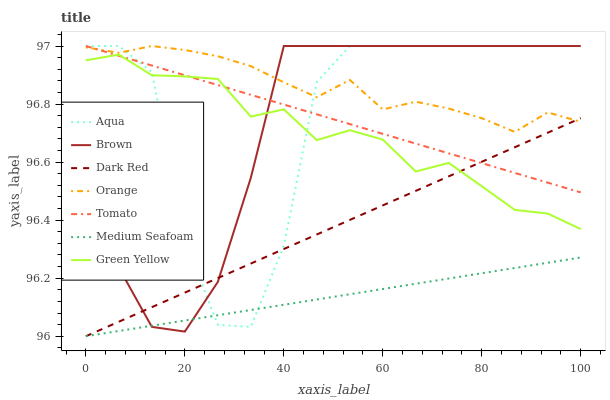Does Medium Seafoam have the minimum area under the curve?
Answer yes or no. Yes. Does Orange have the maximum area under the curve?
Answer yes or no. Yes. Does Brown have the minimum area under the curve?
Answer yes or no. No. Does Brown have the maximum area under the curve?
Answer yes or no. No. Is Tomato the smoothest?
Answer yes or no. Yes. Is Aqua the roughest?
Answer yes or no. Yes. Is Brown the smoothest?
Answer yes or no. No. Is Brown the roughest?
Answer yes or no. No. Does Dark Red have the lowest value?
Answer yes or no. Yes. Does Brown have the lowest value?
Answer yes or no. No. Does Orange have the highest value?
Answer yes or no. Yes. Does Dark Red have the highest value?
Answer yes or no. No. Is Medium Seafoam less than Green Yellow?
Answer yes or no. Yes. Is Orange greater than Green Yellow?
Answer yes or no. Yes. Does Brown intersect Aqua?
Answer yes or no. Yes. Is Brown less than Aqua?
Answer yes or no. No. Is Brown greater than Aqua?
Answer yes or no. No. Does Medium Seafoam intersect Green Yellow?
Answer yes or no. No. 